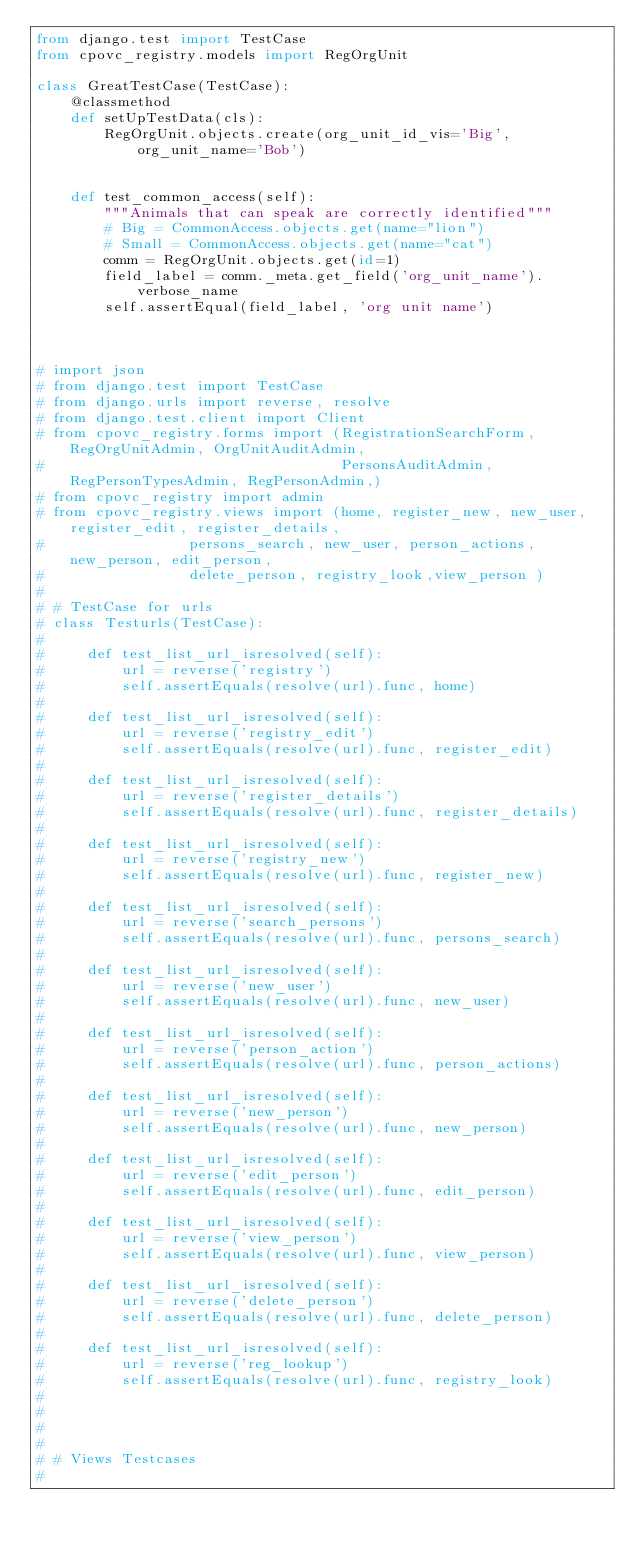<code> <loc_0><loc_0><loc_500><loc_500><_Python_>from django.test import TestCase
from cpovc_registry.models import RegOrgUnit

class GreatTestCase(TestCase):
    @classmethod
    def setUpTestData(cls):
        RegOrgUnit.objects.create(org_unit_id_vis='Big', org_unit_name='Bob')


    def test_common_access(self):
        """Animals that can speak are correctly identified"""
        # Big = CommonAccess.objects.get(name="lion")
        # Small = CommonAccess.objects.get(name="cat")
        comm = RegOrgUnit.objects.get(id=1)
        field_label = comm._meta.get_field('org_unit_name').verbose_name
        self.assertEqual(field_label, 'org unit name')



# import json
# from django.test import TestCase
# from django.urls import reverse, resolve
# from django.test.client import Client
# from cpovc_registry.forms import (RegistrationSearchForm, RegOrgUnitAdmin, OrgUnitAuditAdmin,
#                                   PersonsAuditAdmin, RegPersonTypesAdmin, RegPersonAdmin,)
# from cpovc_registry import admin
# from cpovc_registry.views import (home, register_new, new_user, register_edit, register_details,
#                 persons_search, new_user, person_actions, new_person, edit_person,
#                 delete_person, registry_look,view_person )
#
# # TestCase for urls
# class Testurls(TestCase):
#
#     def test_list_url_isresolved(self):
#         url = reverse('registry')
#         self.assertEquals(resolve(url).func, home)
#
#     def test_list_url_isresolved(self):
#         url = reverse('registry_edit')
#         self.assertEquals(resolve(url).func, register_edit)
#
#     def test_list_url_isresolved(self):
#         url = reverse('register_details')
#         self.assertEquals(resolve(url).func, register_details)
#
#     def test_list_url_isresolved(self):
#         url = reverse('registry_new')
#         self.assertEquals(resolve(url).func, register_new)
#
#     def test_list_url_isresolved(self):
#         url = reverse('search_persons')
#         self.assertEquals(resolve(url).func, persons_search)
#
#     def test_list_url_isresolved(self):
#         url = reverse('new_user')
#         self.assertEquals(resolve(url).func, new_user)
#
#     def test_list_url_isresolved(self):
#         url = reverse('person_action')
#         self.assertEquals(resolve(url).func, person_actions)
#
#     def test_list_url_isresolved(self):
#         url = reverse('new_person')
#         self.assertEquals(resolve(url).func, new_person)
#
#     def test_list_url_isresolved(self):
#         url = reverse('edit_person')
#         self.assertEquals(resolve(url).func, edit_person)
#
#     def test_list_url_isresolved(self):
#         url = reverse('view_person')
#         self.assertEquals(resolve(url).func, view_person)
#
#     def test_list_url_isresolved(self):
#         url = reverse('delete_person')
#         self.assertEquals(resolve(url).func, delete_person)
#
#     def test_list_url_isresolved(self):
#         url = reverse('reg_lookup')
#         self.assertEquals(resolve(url).func, registry_look)
#
#
#
#
# # Views Testcases
#</code> 